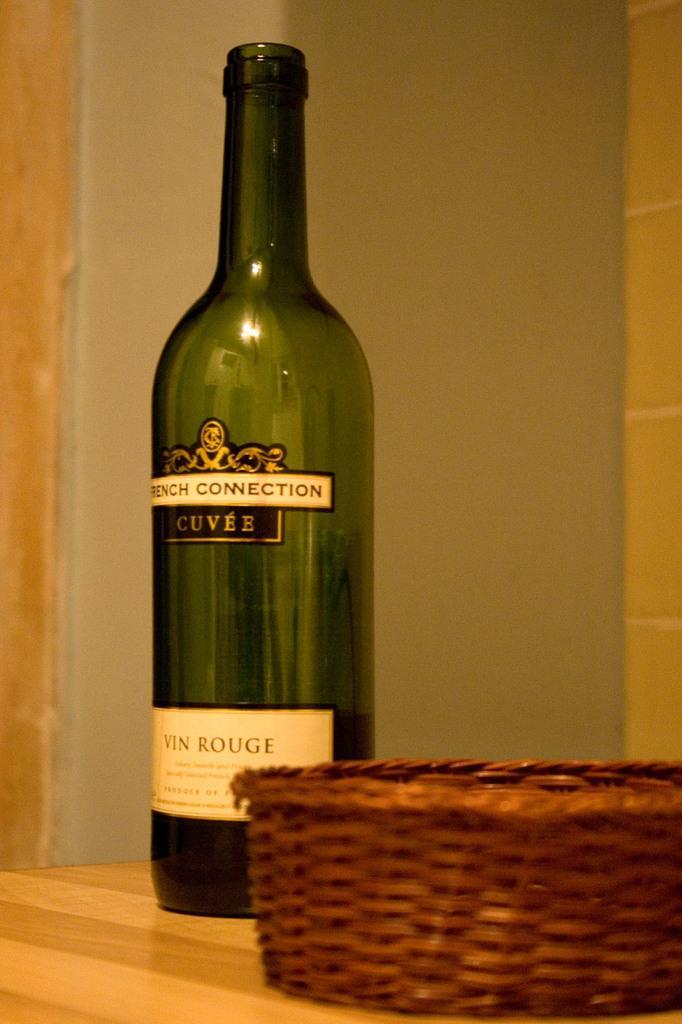Could you give a brief overview of what you see in this image? In this picture i could see green colored wine bottle placed on the table and beside the wine bottle there is a basket which is brown in color. In the background i could see a yellow colored wall. 